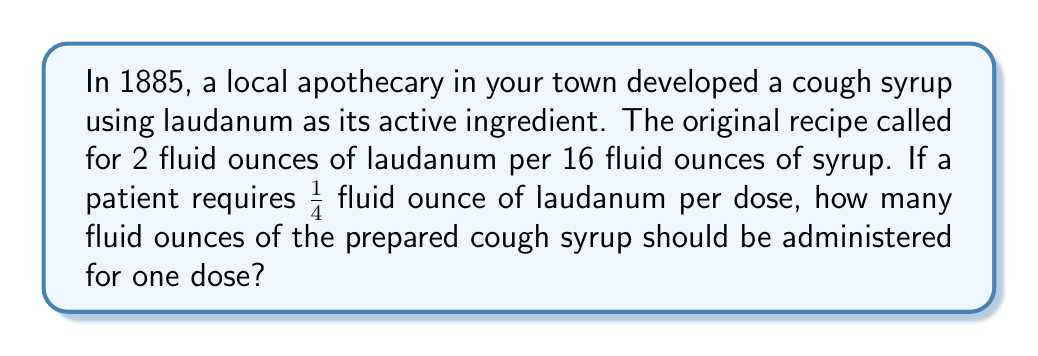Can you answer this question? Let's approach this step-by-step:

1) First, we need to establish the ratio of laudanum to syrup in the original recipe:
   $$\frac{2 \text{ fl oz laudanum}}{16 \text{ fl oz syrup}} = \frac{1 \text{ fl oz laudanum}}{8 \text{ fl oz syrup}}$$

2) Now, we know that one dose should contain 1/4 fl oz of laudanum. Let's call the amount of syrup we're looking for $x$. We can set up a proportion:
   $$\frac{1 \text{ fl oz laudanum}}{8 \text{ fl oz syrup}} = \frac{1/4 \text{ fl oz laudanum}}{x \text{ fl oz syrup}}$$

3) Cross multiply:
   $$1 \cdot x = 8 \cdot \frac{1}{4}$$

4) Simplify the right side:
   $$x = 8 \cdot \frac{1}{4} = 2$$

5) Therefore, $x = 2$ fl oz of syrup.

6) Remember, this 2 fl oz of syrup already contains the required 1/4 fl oz of laudanum, so this is the final amount to be administered.
Answer: 2 fluid ounces 